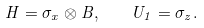<formula> <loc_0><loc_0><loc_500><loc_500>H = \sigma _ { x } \otimes B , \quad U _ { 1 } = \sigma _ { z } .</formula> 